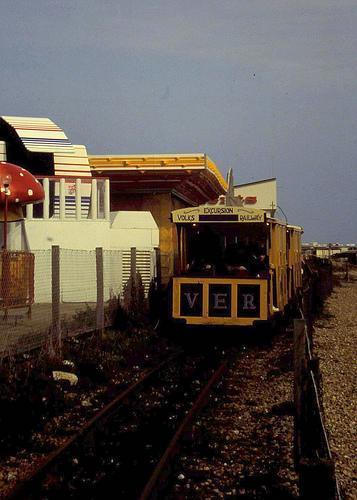How many tracks are there?
Give a very brief answer. 1. 